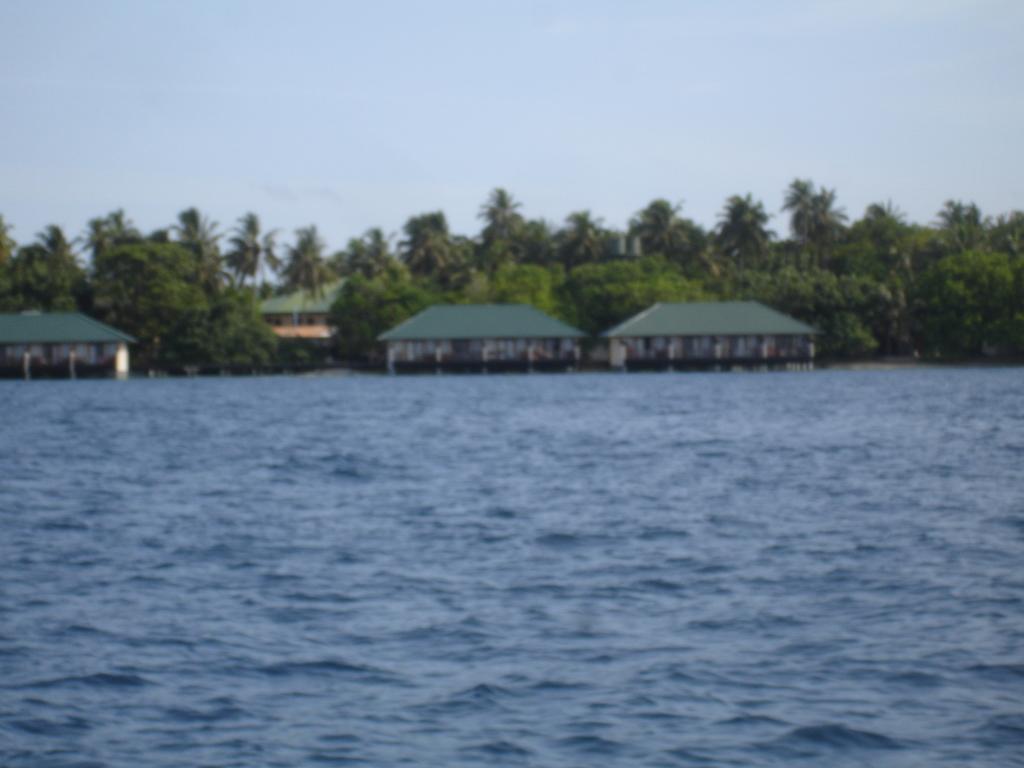Please provide a concise description of this image. In the foreground of the picture there is water. In the center of the picture there are trees, palm trees and houses. Sky is clear. 